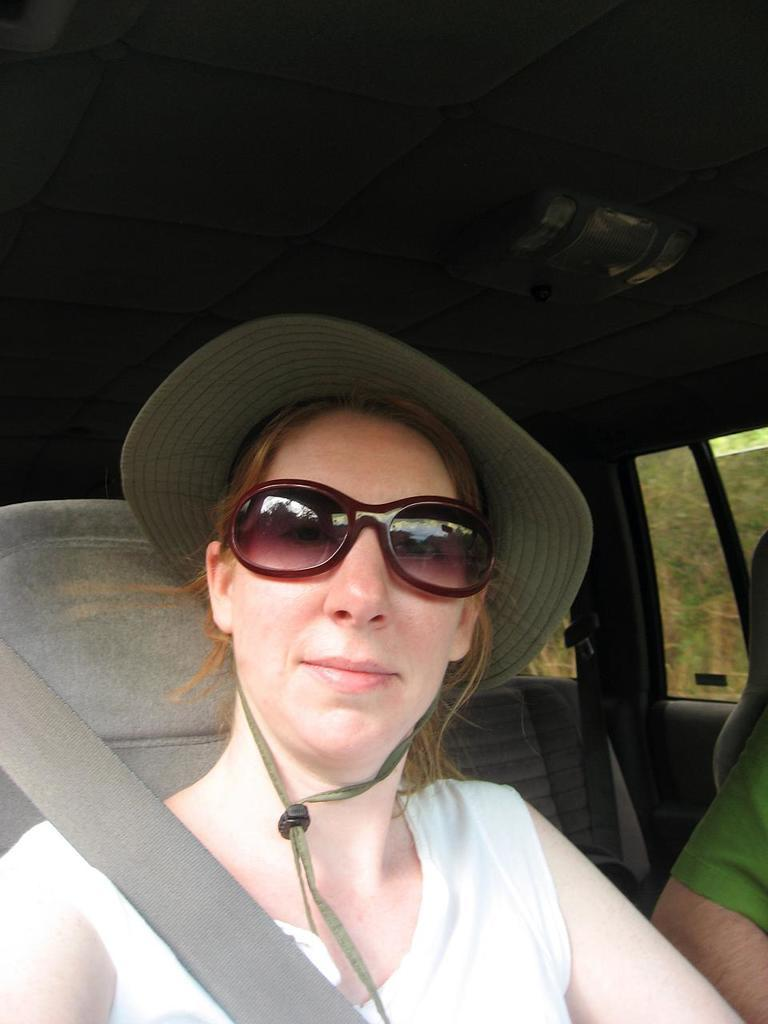What is the main subject in the center of the image? There is a vehicle in the center of the image. Who or what is inside the vehicle? There is a person sitting in the vehicle. Can you describe the person's appearance? The person is wearing a hat. What type of disease is the person in the vehicle suffering from in the image? There is no indication of any disease in the image; the person is simply sitting in the vehicle wearing a hat. 